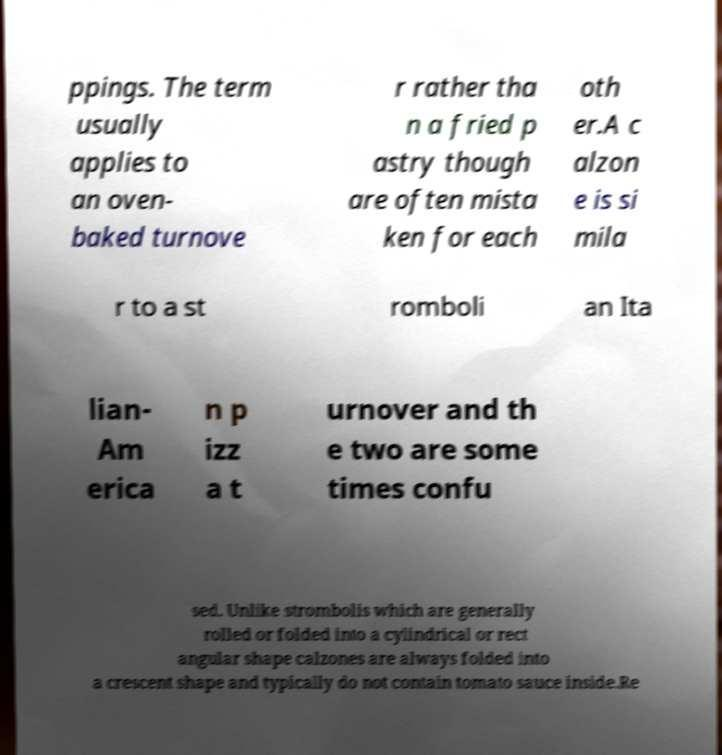Could you assist in decoding the text presented in this image and type it out clearly? ppings. The term usually applies to an oven- baked turnove r rather tha n a fried p astry though are often mista ken for each oth er.A c alzon e is si mila r to a st romboli an Ita lian- Am erica n p izz a t urnover and th e two are some times confu sed. Unlike strombolis which are generally rolled or folded into a cylindrical or rect angular shape calzones are always folded into a crescent shape and typically do not contain tomato sauce inside.Re 